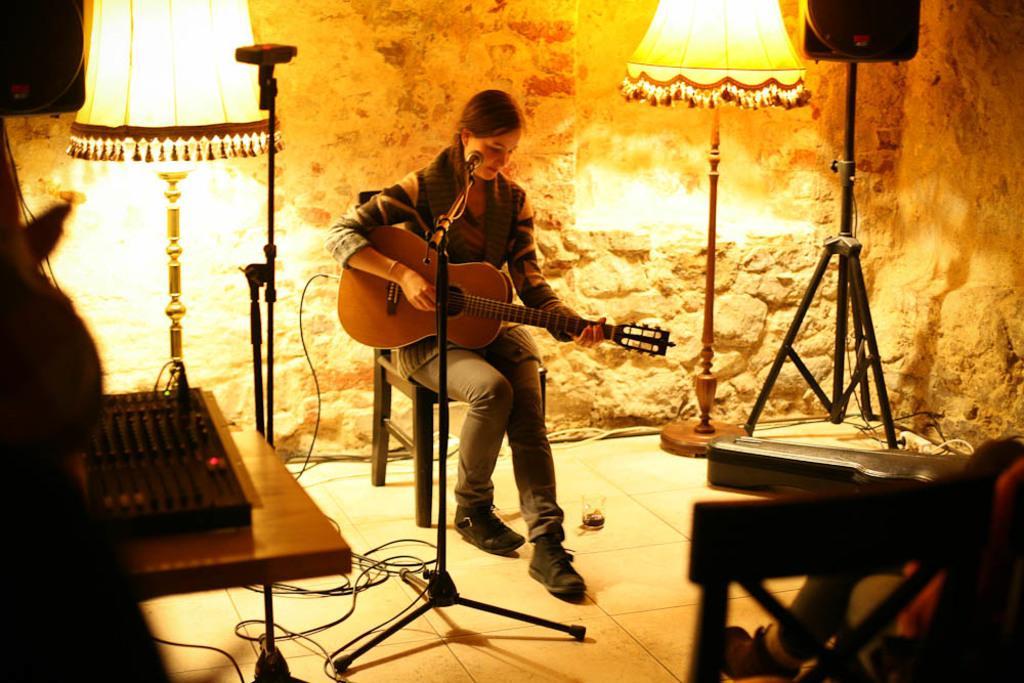Describe this image in one or two sentences. In this image in the center there is one woman sitting on chair, and she is holding a guitar. In front of her there is one mike, and on the left side there is lamp speaker table on the table there is a keyboard and some other objects. And at the bottom there are some wires, on the right side also there is one lamp, speaker, one person and some objects. 